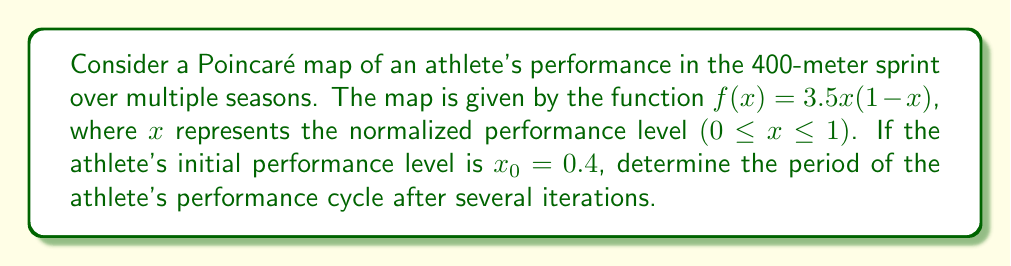Show me your answer to this math problem. To determine the periodicity of the athlete's performance cycle, we need to iterate the Poincaré map and observe when (if ever) the performance level returns to its initial value. Let's follow these steps:

1) Start with $x_0 = 0.4$

2) Calculate successive iterations:
   $x_1 = f(x_0) = 3.5(0.4)(1-0.4) = 0.84$
   $x_2 = f(x_1) = 3.5(0.84)(1-0.84) = 0.4704$
   $x_3 = f(x_2) = 3.5(0.4704)(1-0.4704) \approx 0.8737$
   $x_4 = f(x_3) \approx 0.3870$

3) We observe that after 4 iterations, the value is close to, but not exactly, the initial value of 0.4.

4) Continuing the iterations:
   $x_5 \approx 0.8313$
   $x_6 \approx 0.4920$
   $x_7 \approx 0.8752$
   $x_8 \approx 0.3833$

5) After 8 iterations, we're again close to, but not exactly at, the initial value.

6) This pattern continues indefinitely, never exactly repeating but always staying within a certain range.

7) In dynamical systems theory, this behavior is known as a quasi-periodic orbit. The orbit doesn't have a finite period, but it does exhibit a regular, recurring pattern.

Therefore, we conclude that this athlete's performance cycle, as modeled by this Poincaré map, does not have a finite period but instead exhibits quasi-periodic behavior.
Answer: Quasi-periodic (no finite period) 